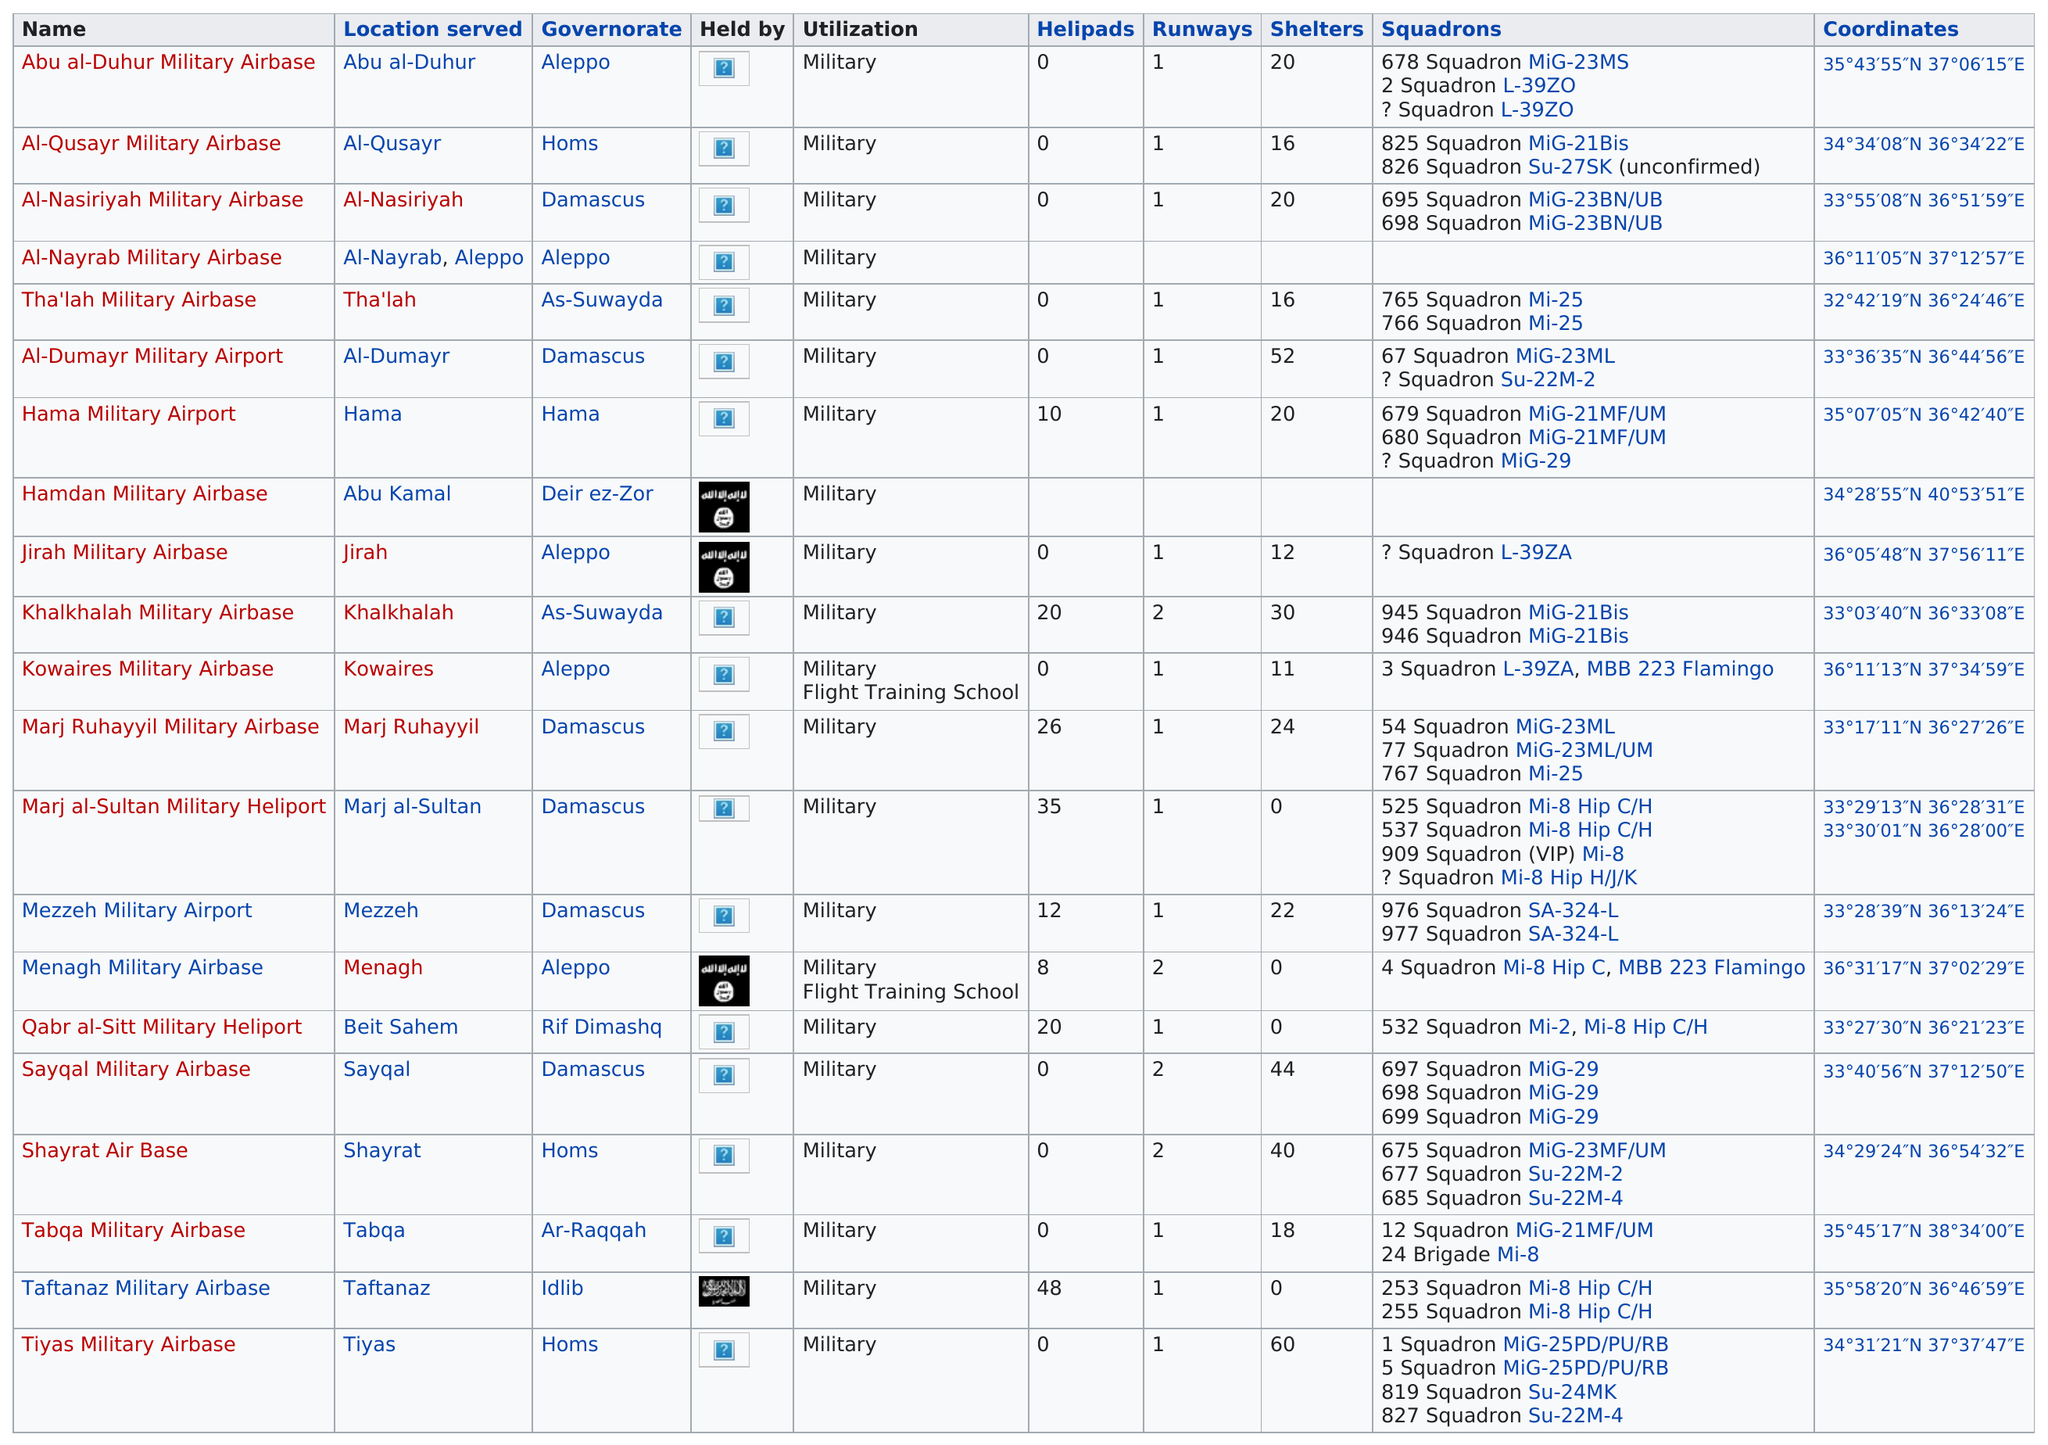Highlight a few significant elements in this photo. The Syrian civil defense forces reported that there were two runways at the Shayrat Air Base, which was subject to a chemical weapons attack in April 2017. It is not the case that any airbase has the same location as Thalah Military Airbase. Kowaires Military Airbase and Menagh Military Airbase are the only two locations that offer military flight training. There are eight airbases that have helipads. The second name has fewer than 20 shelters. 